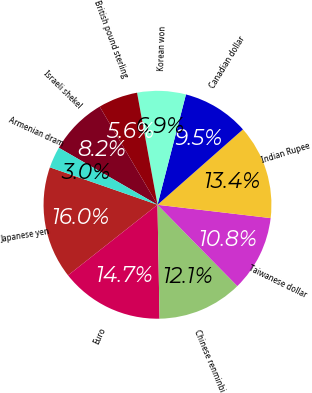Convert chart. <chart><loc_0><loc_0><loc_500><loc_500><pie_chart><fcel>Japanese yen<fcel>Euro<fcel>Chinese renminbi<fcel>Taiwanese dollar<fcel>Indian Rupee<fcel>Canadian dollar<fcel>Korean won<fcel>British pound sterling<fcel>Israeli shekel<fcel>Armenian dram<nl><fcel>15.96%<fcel>14.66%<fcel>12.07%<fcel>10.78%<fcel>13.37%<fcel>9.48%<fcel>6.89%<fcel>5.6%<fcel>8.19%<fcel>3.01%<nl></chart> 